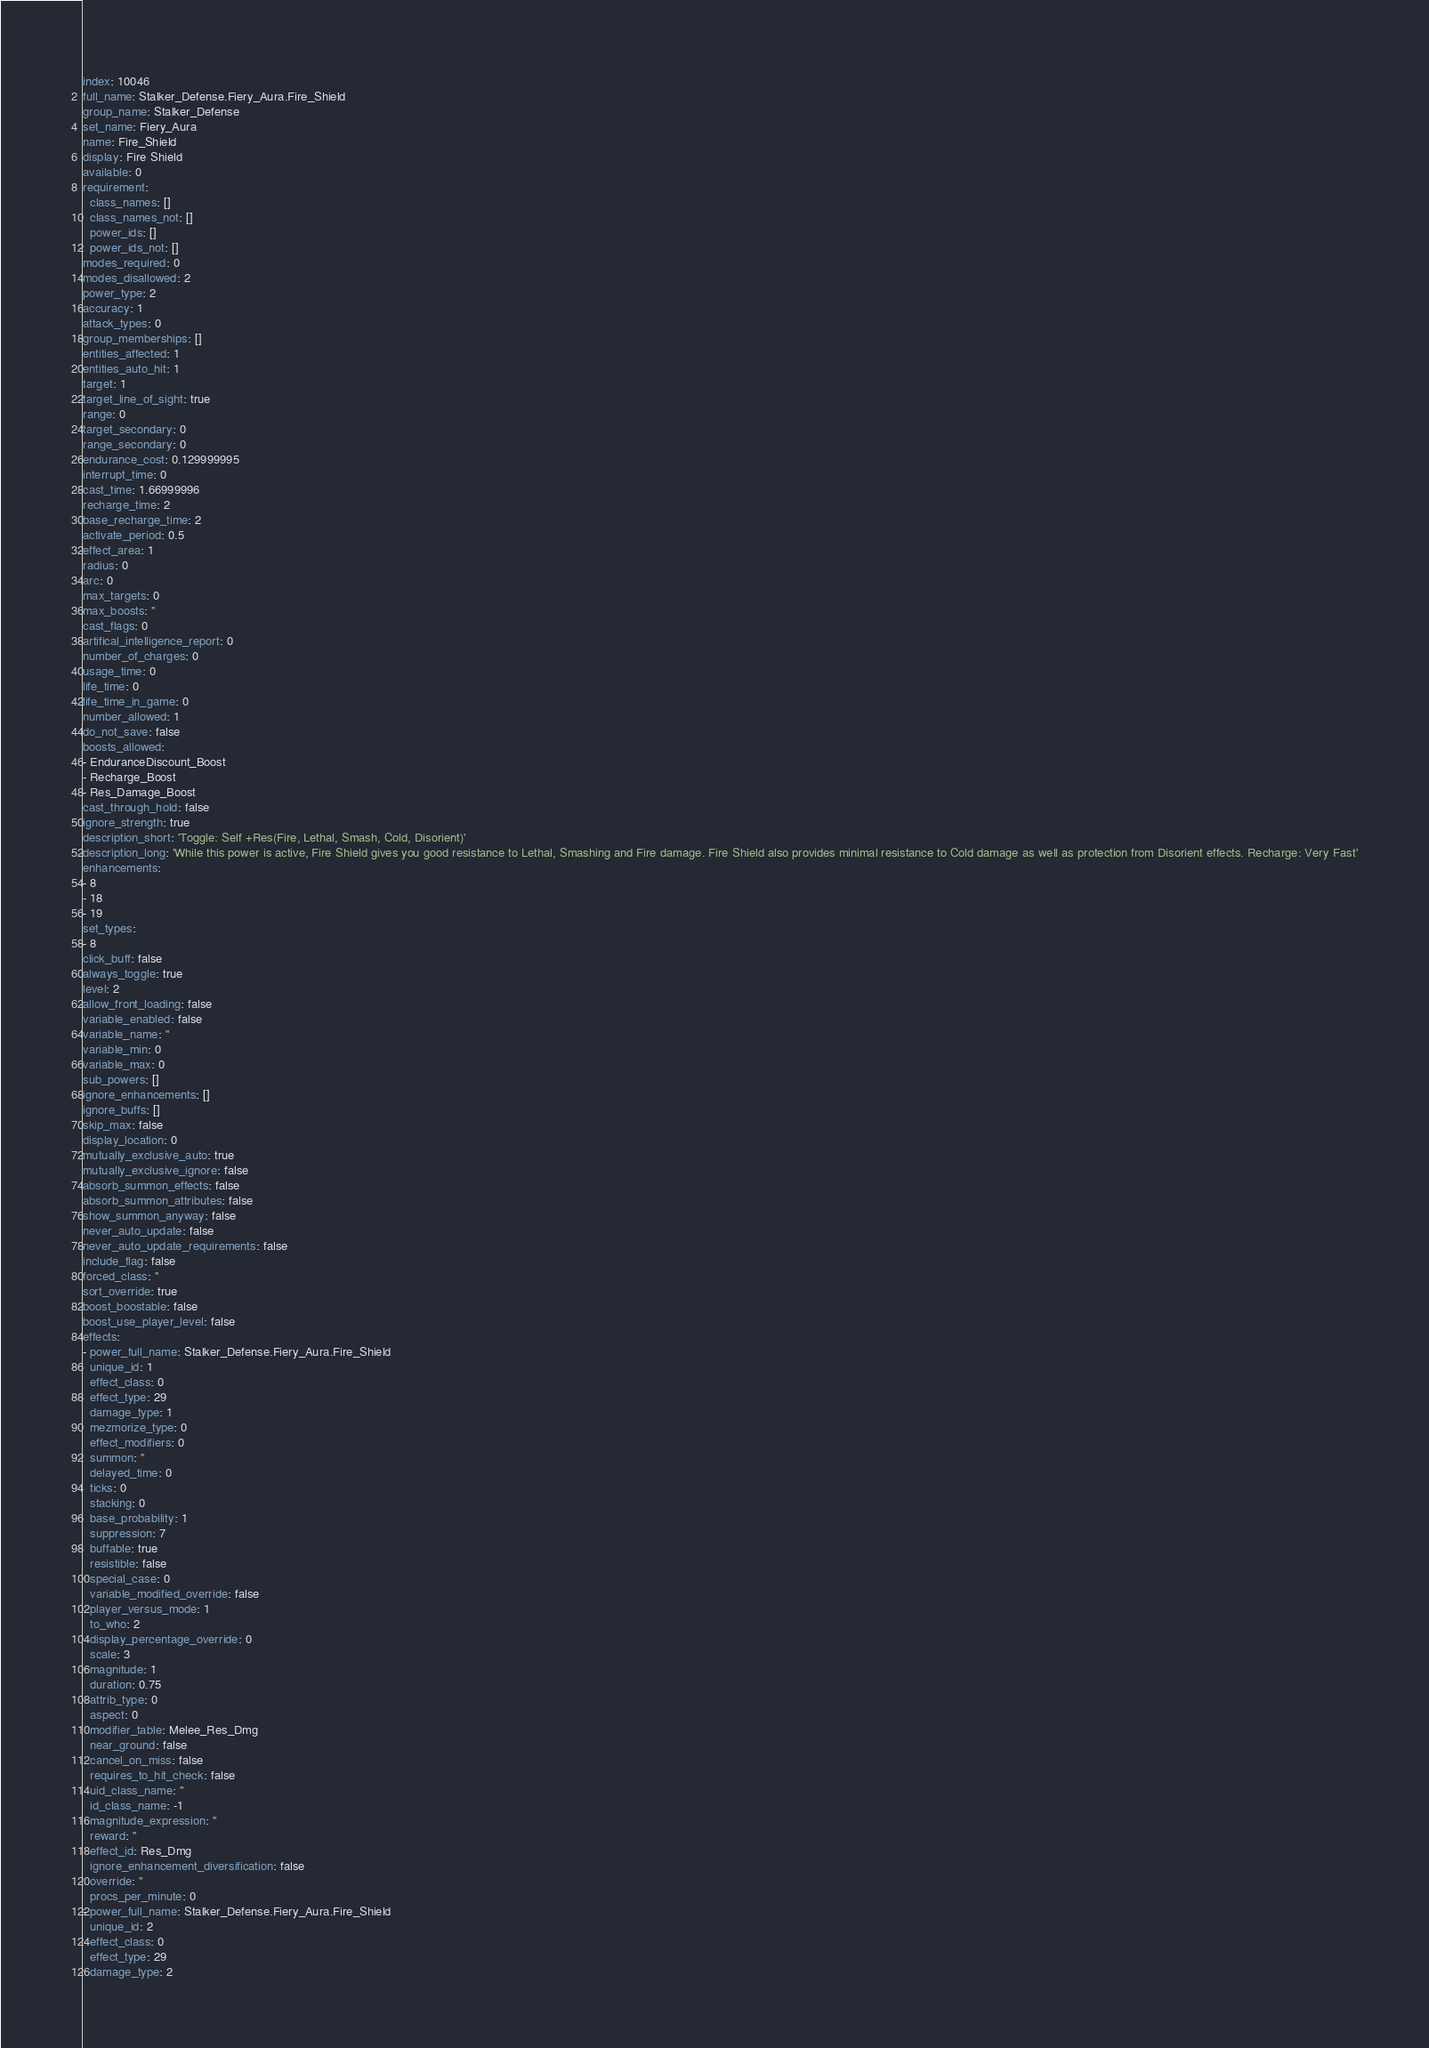Convert code to text. <code><loc_0><loc_0><loc_500><loc_500><_YAML_>index: 10046
full_name: Stalker_Defense.Fiery_Aura.Fire_Shield
group_name: Stalker_Defense
set_name: Fiery_Aura
name: Fire_Shield
display: Fire Shield
available: 0
requirement:
  class_names: []
  class_names_not: []
  power_ids: []
  power_ids_not: []
modes_required: 0
modes_disallowed: 2
power_type: 2
accuracy: 1
attack_types: 0
group_memberships: []
entities_affected: 1
entities_auto_hit: 1
target: 1
target_line_of_sight: true
range: 0
target_secondary: 0
range_secondary: 0
endurance_cost: 0.129999995
interrupt_time: 0
cast_time: 1.66999996
recharge_time: 2
base_recharge_time: 2
activate_period: 0.5
effect_area: 1
radius: 0
arc: 0
max_targets: 0
max_boosts: ''
cast_flags: 0
artifical_intelligence_report: 0
number_of_charges: 0
usage_time: 0
life_time: 0
life_time_in_game: 0
number_allowed: 1
do_not_save: false
boosts_allowed:
- EnduranceDiscount_Boost
- Recharge_Boost
- Res_Damage_Boost
cast_through_hold: false
ignore_strength: true
description_short: 'Toggle: Self +Res(Fire, Lethal, Smash, Cold, Disorient)'
description_long: 'While this power is active, Fire Shield gives you good resistance to Lethal, Smashing and Fire damage. Fire Shield also provides minimal resistance to Cold damage as well as protection from Disorient effects. Recharge: Very Fast'
enhancements:
- 8
- 18
- 19
set_types:
- 8
click_buff: false
always_toggle: true
level: 2
allow_front_loading: false
variable_enabled: false
variable_name: ''
variable_min: 0
variable_max: 0
sub_powers: []
ignore_enhancements: []
ignore_buffs: []
skip_max: false
display_location: 0
mutually_exclusive_auto: true
mutually_exclusive_ignore: false
absorb_summon_effects: false
absorb_summon_attributes: false
show_summon_anyway: false
never_auto_update: false
never_auto_update_requirements: false
include_flag: false
forced_class: ''
sort_override: true
boost_boostable: false
boost_use_player_level: false
effects:
- power_full_name: Stalker_Defense.Fiery_Aura.Fire_Shield
  unique_id: 1
  effect_class: 0
  effect_type: 29
  damage_type: 1
  mezmorize_type: 0
  effect_modifiers: 0
  summon: ''
  delayed_time: 0
  ticks: 0
  stacking: 0
  base_probability: 1
  suppression: 7
  buffable: true
  resistible: false
  special_case: 0
  variable_modified_override: false
  player_versus_mode: 1
  to_who: 2
  display_percentage_override: 0
  scale: 3
  magnitude: 1
  duration: 0.75
  attrib_type: 0
  aspect: 0
  modifier_table: Melee_Res_Dmg
  near_ground: false
  cancel_on_miss: false
  requires_to_hit_check: false
  uid_class_name: ''
  id_class_name: -1
  magnitude_expression: ''
  reward: ''
  effect_id: Res_Dmg
  ignore_enhancement_diversification: false
  override: ''
  procs_per_minute: 0
- power_full_name: Stalker_Defense.Fiery_Aura.Fire_Shield
  unique_id: 2
  effect_class: 0
  effect_type: 29
  damage_type: 2</code> 